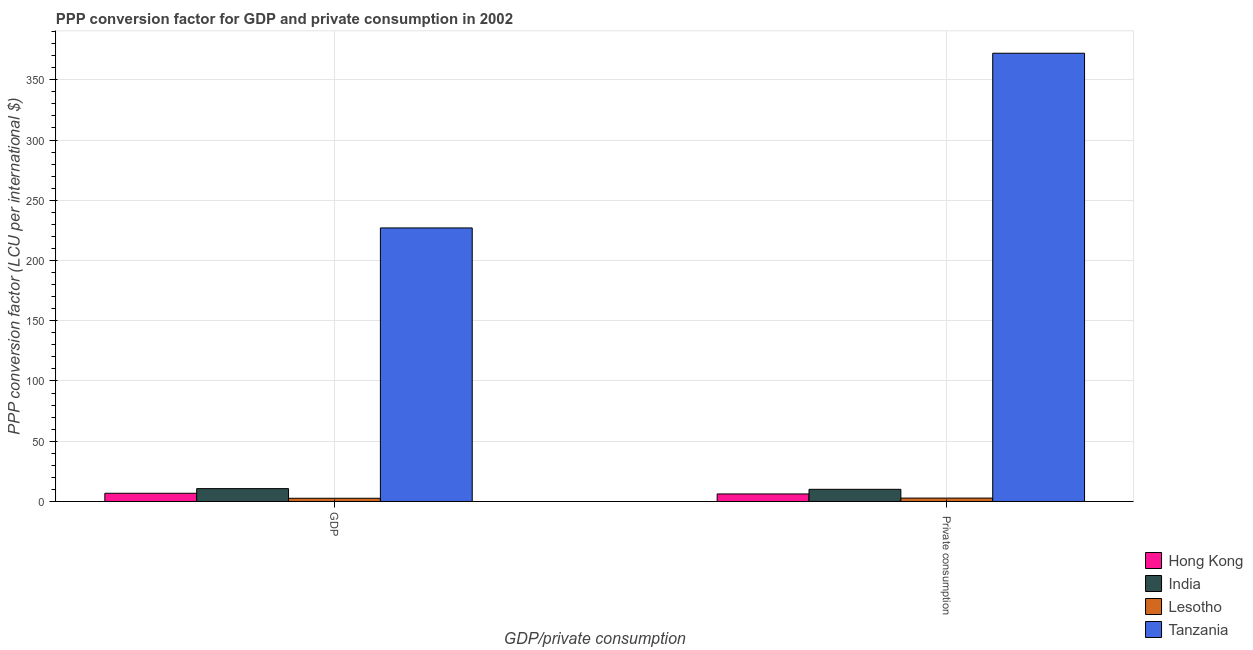How many groups of bars are there?
Give a very brief answer. 2. Are the number of bars per tick equal to the number of legend labels?
Provide a succinct answer. Yes. How many bars are there on the 1st tick from the left?
Offer a very short reply. 4. What is the label of the 2nd group of bars from the left?
Your answer should be compact.  Private consumption. What is the ppp conversion factor for private consumption in Hong Kong?
Make the answer very short. 6.24. Across all countries, what is the maximum ppp conversion factor for private consumption?
Ensure brevity in your answer.  372.05. Across all countries, what is the minimum ppp conversion factor for gdp?
Your answer should be very brief. 2.65. In which country was the ppp conversion factor for private consumption maximum?
Your answer should be compact. Tanzania. In which country was the ppp conversion factor for private consumption minimum?
Give a very brief answer. Lesotho. What is the total ppp conversion factor for private consumption in the graph?
Give a very brief answer. 391.2. What is the difference between the ppp conversion factor for private consumption in Hong Kong and that in India?
Offer a very short reply. -3.84. What is the difference between the ppp conversion factor for private consumption in India and the ppp conversion factor for gdp in Tanzania?
Provide a short and direct response. -216.96. What is the average ppp conversion factor for gdp per country?
Offer a terse response. 61.79. What is the difference between the ppp conversion factor for private consumption and ppp conversion factor for gdp in Lesotho?
Your answer should be very brief. 0.16. What is the ratio of the ppp conversion factor for private consumption in Tanzania to that in Lesotho?
Make the answer very short. 132.17. In how many countries, is the ppp conversion factor for gdp greater than the average ppp conversion factor for gdp taken over all countries?
Your answer should be very brief. 1. What does the 4th bar from the left in  Private consumption represents?
Your answer should be very brief. Tanzania. How many bars are there?
Keep it short and to the point. 8. Are the values on the major ticks of Y-axis written in scientific E-notation?
Your answer should be very brief. No. Does the graph contain any zero values?
Make the answer very short. No. What is the title of the graph?
Offer a terse response. PPP conversion factor for GDP and private consumption in 2002. Does "Senegal" appear as one of the legend labels in the graph?
Your response must be concise. No. What is the label or title of the X-axis?
Make the answer very short. GDP/private consumption. What is the label or title of the Y-axis?
Keep it short and to the point. PPP conversion factor (LCU per international $). What is the PPP conversion factor (LCU per international $) of Hong Kong in GDP?
Your answer should be very brief. 6.8. What is the PPP conversion factor (LCU per international $) of India in GDP?
Your answer should be compact. 10.66. What is the PPP conversion factor (LCU per international $) in Lesotho in GDP?
Offer a very short reply. 2.65. What is the PPP conversion factor (LCU per international $) of Tanzania in GDP?
Provide a succinct answer. 227.05. What is the PPP conversion factor (LCU per international $) in Hong Kong in  Private consumption?
Make the answer very short. 6.24. What is the PPP conversion factor (LCU per international $) in India in  Private consumption?
Offer a very short reply. 10.08. What is the PPP conversion factor (LCU per international $) in Lesotho in  Private consumption?
Your answer should be compact. 2.82. What is the PPP conversion factor (LCU per international $) of Tanzania in  Private consumption?
Your answer should be very brief. 372.05. Across all GDP/private consumption, what is the maximum PPP conversion factor (LCU per international $) in Hong Kong?
Your answer should be compact. 6.8. Across all GDP/private consumption, what is the maximum PPP conversion factor (LCU per international $) in India?
Your response must be concise. 10.66. Across all GDP/private consumption, what is the maximum PPP conversion factor (LCU per international $) in Lesotho?
Your answer should be compact. 2.82. Across all GDP/private consumption, what is the maximum PPP conversion factor (LCU per international $) of Tanzania?
Give a very brief answer. 372.05. Across all GDP/private consumption, what is the minimum PPP conversion factor (LCU per international $) of Hong Kong?
Your response must be concise. 6.24. Across all GDP/private consumption, what is the minimum PPP conversion factor (LCU per international $) in India?
Your response must be concise. 10.08. Across all GDP/private consumption, what is the minimum PPP conversion factor (LCU per international $) in Lesotho?
Your answer should be very brief. 2.65. Across all GDP/private consumption, what is the minimum PPP conversion factor (LCU per international $) of Tanzania?
Ensure brevity in your answer.  227.05. What is the total PPP conversion factor (LCU per international $) in Hong Kong in the graph?
Give a very brief answer. 13.04. What is the total PPP conversion factor (LCU per international $) of India in the graph?
Ensure brevity in your answer.  20.75. What is the total PPP conversion factor (LCU per international $) of Lesotho in the graph?
Ensure brevity in your answer.  5.47. What is the total PPP conversion factor (LCU per international $) in Tanzania in the graph?
Provide a succinct answer. 599.1. What is the difference between the PPP conversion factor (LCU per international $) of Hong Kong in GDP and that in  Private consumption?
Offer a very short reply. 0.56. What is the difference between the PPP conversion factor (LCU per international $) of India in GDP and that in  Private consumption?
Ensure brevity in your answer.  0.58. What is the difference between the PPP conversion factor (LCU per international $) of Lesotho in GDP and that in  Private consumption?
Keep it short and to the point. -0.16. What is the difference between the PPP conversion factor (LCU per international $) of Tanzania in GDP and that in  Private consumption?
Keep it short and to the point. -145.01. What is the difference between the PPP conversion factor (LCU per international $) of Hong Kong in GDP and the PPP conversion factor (LCU per international $) of India in  Private consumption?
Provide a short and direct response. -3.28. What is the difference between the PPP conversion factor (LCU per international $) in Hong Kong in GDP and the PPP conversion factor (LCU per international $) in Lesotho in  Private consumption?
Keep it short and to the point. 3.99. What is the difference between the PPP conversion factor (LCU per international $) of Hong Kong in GDP and the PPP conversion factor (LCU per international $) of Tanzania in  Private consumption?
Provide a short and direct response. -365.25. What is the difference between the PPP conversion factor (LCU per international $) of India in GDP and the PPP conversion factor (LCU per international $) of Lesotho in  Private consumption?
Ensure brevity in your answer.  7.85. What is the difference between the PPP conversion factor (LCU per international $) in India in GDP and the PPP conversion factor (LCU per international $) in Tanzania in  Private consumption?
Offer a very short reply. -361.39. What is the difference between the PPP conversion factor (LCU per international $) in Lesotho in GDP and the PPP conversion factor (LCU per international $) in Tanzania in  Private consumption?
Your answer should be compact. -369.4. What is the average PPP conversion factor (LCU per international $) in Hong Kong per GDP/private consumption?
Your answer should be compact. 6.52. What is the average PPP conversion factor (LCU per international $) of India per GDP/private consumption?
Your answer should be very brief. 10.37. What is the average PPP conversion factor (LCU per international $) of Lesotho per GDP/private consumption?
Make the answer very short. 2.73. What is the average PPP conversion factor (LCU per international $) of Tanzania per GDP/private consumption?
Offer a terse response. 299.55. What is the difference between the PPP conversion factor (LCU per international $) of Hong Kong and PPP conversion factor (LCU per international $) of India in GDP?
Offer a terse response. -3.86. What is the difference between the PPP conversion factor (LCU per international $) of Hong Kong and PPP conversion factor (LCU per international $) of Lesotho in GDP?
Offer a very short reply. 4.15. What is the difference between the PPP conversion factor (LCU per international $) of Hong Kong and PPP conversion factor (LCU per international $) of Tanzania in GDP?
Your response must be concise. -220.25. What is the difference between the PPP conversion factor (LCU per international $) in India and PPP conversion factor (LCU per international $) in Lesotho in GDP?
Keep it short and to the point. 8.01. What is the difference between the PPP conversion factor (LCU per international $) in India and PPP conversion factor (LCU per international $) in Tanzania in GDP?
Keep it short and to the point. -216.39. What is the difference between the PPP conversion factor (LCU per international $) in Lesotho and PPP conversion factor (LCU per international $) in Tanzania in GDP?
Offer a terse response. -224.39. What is the difference between the PPP conversion factor (LCU per international $) of Hong Kong and PPP conversion factor (LCU per international $) of India in  Private consumption?
Your answer should be very brief. -3.84. What is the difference between the PPP conversion factor (LCU per international $) of Hong Kong and PPP conversion factor (LCU per international $) of Lesotho in  Private consumption?
Provide a short and direct response. 3.43. What is the difference between the PPP conversion factor (LCU per international $) in Hong Kong and PPP conversion factor (LCU per international $) in Tanzania in  Private consumption?
Make the answer very short. -365.81. What is the difference between the PPP conversion factor (LCU per international $) in India and PPP conversion factor (LCU per international $) in Lesotho in  Private consumption?
Keep it short and to the point. 7.27. What is the difference between the PPP conversion factor (LCU per international $) of India and PPP conversion factor (LCU per international $) of Tanzania in  Private consumption?
Ensure brevity in your answer.  -361.97. What is the difference between the PPP conversion factor (LCU per international $) in Lesotho and PPP conversion factor (LCU per international $) in Tanzania in  Private consumption?
Provide a short and direct response. -369.24. What is the ratio of the PPP conversion factor (LCU per international $) in Hong Kong in GDP to that in  Private consumption?
Your answer should be very brief. 1.09. What is the ratio of the PPP conversion factor (LCU per international $) in India in GDP to that in  Private consumption?
Keep it short and to the point. 1.06. What is the ratio of the PPP conversion factor (LCU per international $) in Lesotho in GDP to that in  Private consumption?
Ensure brevity in your answer.  0.94. What is the ratio of the PPP conversion factor (LCU per international $) of Tanzania in GDP to that in  Private consumption?
Your response must be concise. 0.61. What is the difference between the highest and the second highest PPP conversion factor (LCU per international $) in Hong Kong?
Provide a short and direct response. 0.56. What is the difference between the highest and the second highest PPP conversion factor (LCU per international $) of India?
Your response must be concise. 0.58. What is the difference between the highest and the second highest PPP conversion factor (LCU per international $) in Lesotho?
Offer a very short reply. 0.16. What is the difference between the highest and the second highest PPP conversion factor (LCU per international $) of Tanzania?
Make the answer very short. 145.01. What is the difference between the highest and the lowest PPP conversion factor (LCU per international $) of Hong Kong?
Make the answer very short. 0.56. What is the difference between the highest and the lowest PPP conversion factor (LCU per international $) of India?
Offer a terse response. 0.58. What is the difference between the highest and the lowest PPP conversion factor (LCU per international $) of Lesotho?
Give a very brief answer. 0.16. What is the difference between the highest and the lowest PPP conversion factor (LCU per international $) of Tanzania?
Your response must be concise. 145.01. 